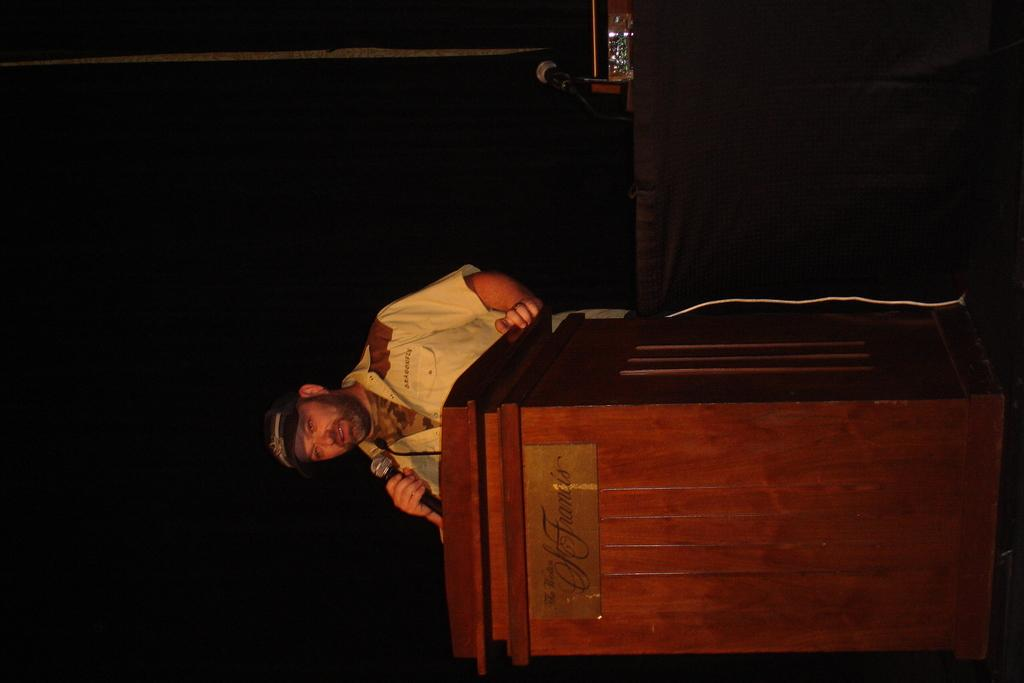What is the main subject in the foreground of the image? There is a man in the foreground of the image. What is the man doing in the image? The man is standing in front of a podium and holding a mic. Are there any other mics visible in the image? Yes, there is another mic in the background of the image. What can be seen in the dark in the background of the image? There is an object in the dark in the background of the image. What type of jam is being spread on the lettuce in the image? There is no jam or lettuce present in the image; it features a man standing in front of a podium with a mic. Is there a playground visible in the image? No, there is no playground present in the image. 